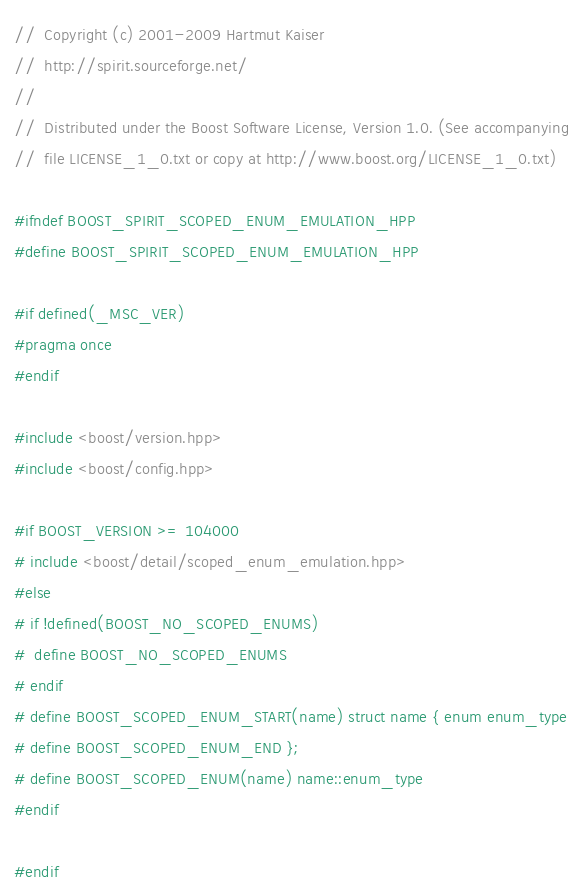Convert code to text. <code><loc_0><loc_0><loc_500><loc_500><_C++_>//  Copyright (c) 2001-2009 Hartmut Kaiser
//  http://spirit.sourceforge.net/
// 
//  Distributed under the Boost Software License, Version 1.0. (See accompanying
//  file LICENSE_1_0.txt or copy at http://www.boost.org/LICENSE_1_0.txt)

#ifndef BOOST_SPIRIT_SCOPED_ENUM_EMULATION_HPP
#define BOOST_SPIRIT_SCOPED_ENUM_EMULATION_HPP

#if defined(_MSC_VER)
#pragma once
#endif

#include <boost/version.hpp>
#include <boost/config.hpp>

#if BOOST_VERSION >= 104000
# include <boost/detail/scoped_enum_emulation.hpp>
#else
# if !defined(BOOST_NO_SCOPED_ENUMS)
#  define BOOST_NO_SCOPED_ENUMS
# endif 
# define BOOST_SCOPED_ENUM_START(name) struct name { enum enum_type
# define BOOST_SCOPED_ENUM_END };
# define BOOST_SCOPED_ENUM(name) name::enum_type
#endif

#endif
</code> 